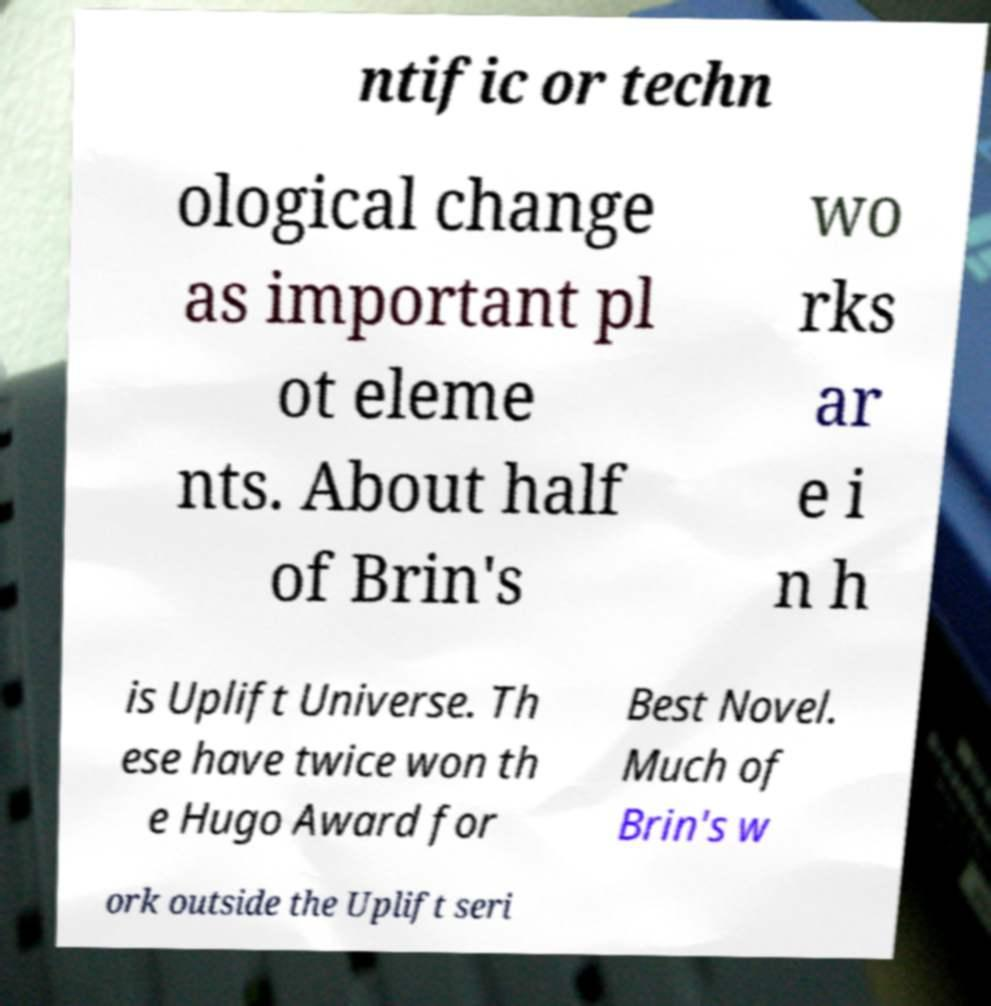Please identify and transcribe the text found in this image. ntific or techn ological change as important pl ot eleme nts. About half of Brin's wo rks ar e i n h is Uplift Universe. Th ese have twice won th e Hugo Award for Best Novel. Much of Brin's w ork outside the Uplift seri 